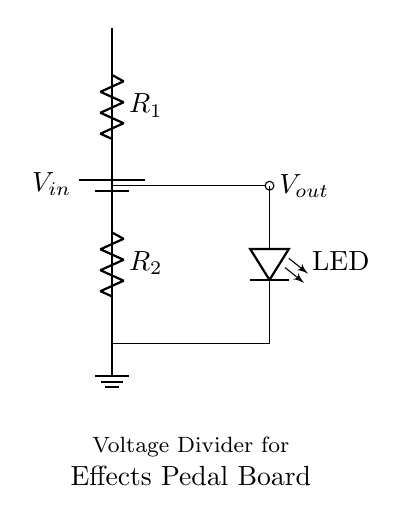What type of circuit is shown? The circuit depicted is a voltage divider, as it consists of two resistors in series designed to divide the input voltage.
Answer: voltage divider What does the LED represent in this circuit? The LED represents an indicator, which shows whether the voltage at that point is sufficient to light it up, indicating power flow or functionality in the effects pedal.
Answer: LED indicator What is the role of R1 and R2? R1 and R2 are resistors that form the voltage dividing network; they determine the output voltage across R2 based on the input voltage.
Answer: resistors What is the output voltage connected to? The output voltage is connected to the LED, indicating that it will receive the divided voltage to operate correctly.
Answer: LED How does the voltage divider function? The voltage divider functions by reducing the input voltage to a lower output voltage determined by the resistance values of R1 and R2, calculated using the formula Vout = Vin * (R2 / (R1 + R2)).
Answer: reduces voltage What happens if R2 is much smaller than R1? If R2 is much smaller than R1, the output voltage Vout will be very low, potentially nearing zero, which means the LED may not light up, indicating insufficient voltage.
Answer: Vout approaches zero What happens if R1 gets shorted? If R1 gets shorted, the entire input voltage Vout will drop to zero, thus cutting off the power to the LED completely, since there will be no voltage drop across R2.
Answer: Vout becomes zero 